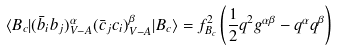<formula> <loc_0><loc_0><loc_500><loc_500>\langle B _ { c } | ( \bar { b } _ { i } b _ { j } ) _ { V - A } ^ { \alpha } ( \bar { c } _ { j } c _ { i } ) _ { V - A } ^ { \beta } | B _ { c } \rangle = f _ { B _ { c } } ^ { 2 } \left ( \frac { 1 } { 2 } q ^ { 2 } g ^ { \alpha \beta } - q ^ { \alpha } q ^ { \beta } \right )</formula> 